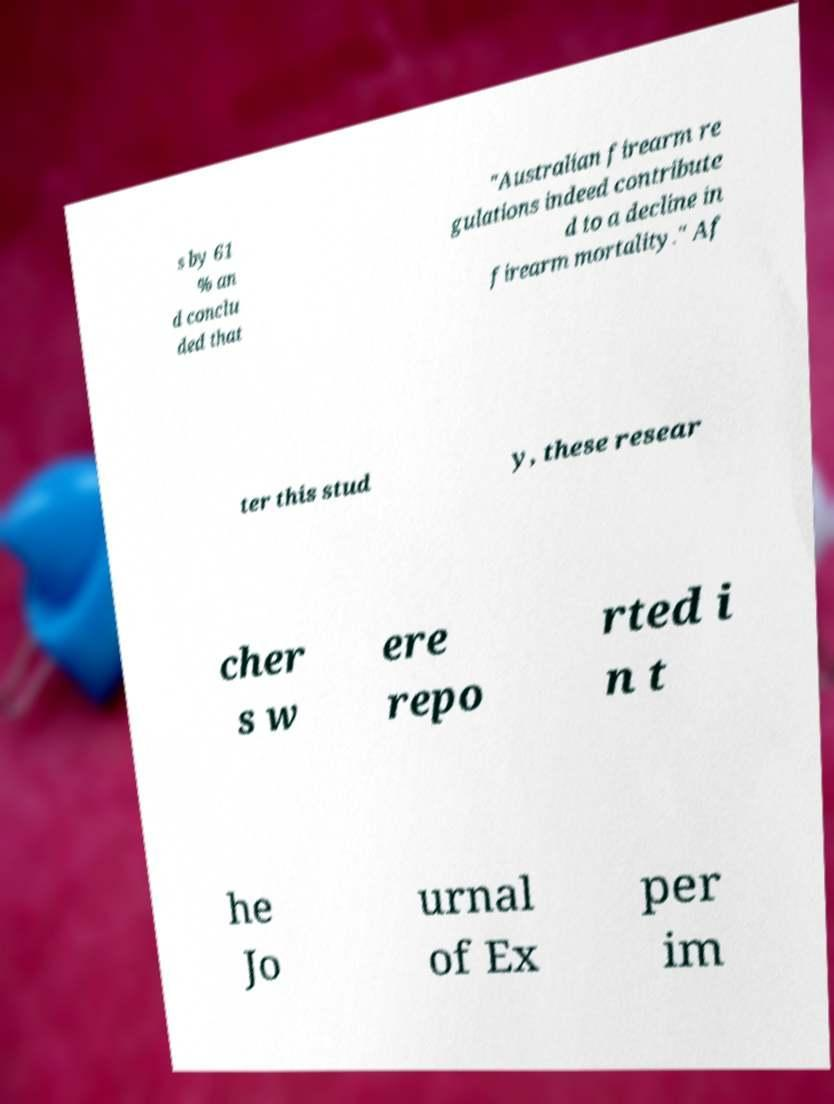Please identify and transcribe the text found in this image. s by 61 % an d conclu ded that "Australian firearm re gulations indeed contribute d to a decline in firearm mortality." Af ter this stud y, these resear cher s w ere repo rted i n t he Jo urnal of Ex per im 